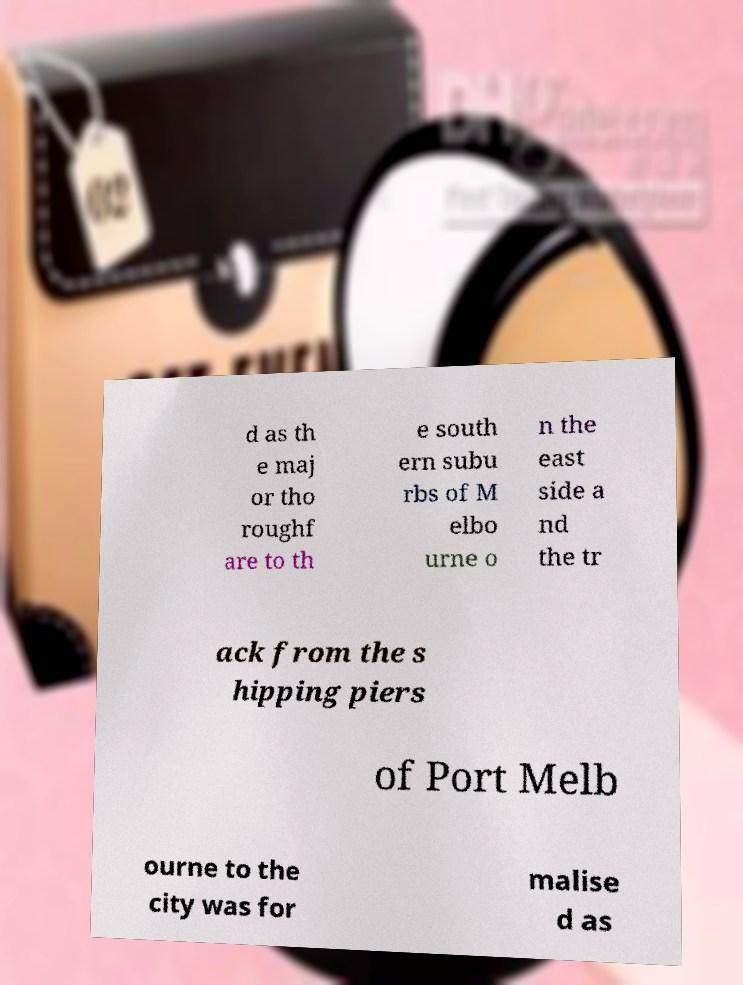Can you read and provide the text displayed in the image?This photo seems to have some interesting text. Can you extract and type it out for me? d as th e maj or tho roughf are to th e south ern subu rbs of M elbo urne o n the east side a nd the tr ack from the s hipping piers of Port Melb ourne to the city was for malise d as 